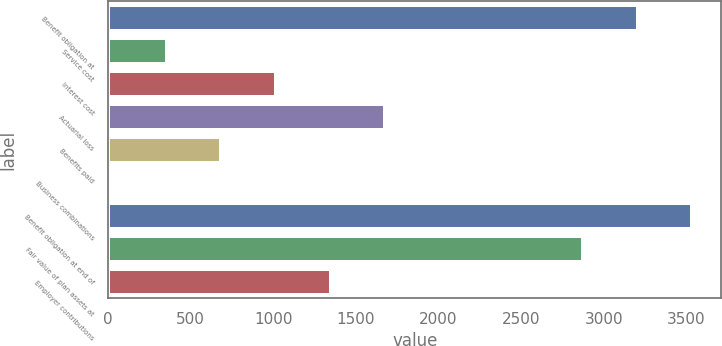<chart> <loc_0><loc_0><loc_500><loc_500><bar_chart><fcel>Benefit obligation at<fcel>Service cost<fcel>Interest cost<fcel>Actuarial loss<fcel>Benefits paid<fcel>Business combinations<fcel>Benefit obligation at end of<fcel>Fair value of plan assets at<fcel>Employer contributions<nl><fcel>3204.56<fcel>355.33<fcel>1015.99<fcel>1676.65<fcel>685.66<fcel>25<fcel>3534.89<fcel>2874.23<fcel>1346.32<nl></chart> 